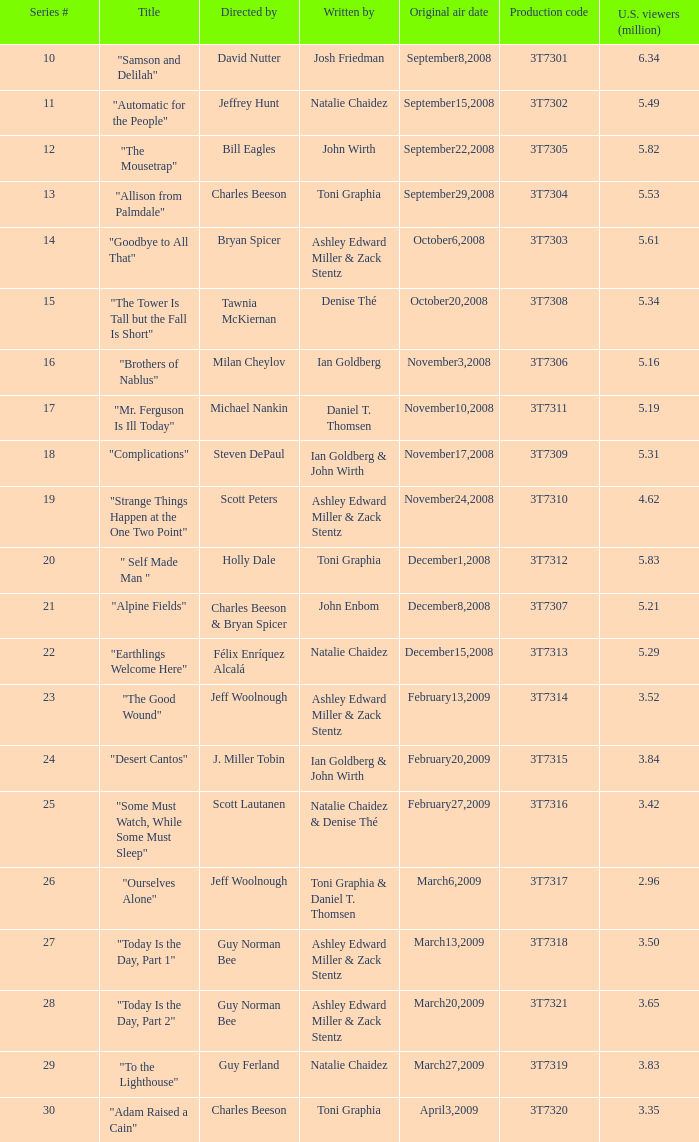Would you be able to parse every entry in this table? {'header': ['Series #', 'Title', 'Directed by', 'Written by', 'Original air date', 'Production code', 'U.S. viewers (million)'], 'rows': [['10', '"Samson and Delilah"', 'David Nutter', 'Josh Friedman', 'September8,2008', '3T7301', '6.34'], ['11', '"Automatic for the People"', 'Jeffrey Hunt', 'Natalie Chaidez', 'September15,2008', '3T7302', '5.49'], ['12', '"The Mousetrap"', 'Bill Eagles', 'John Wirth', 'September22,2008', '3T7305', '5.82'], ['13', '"Allison from Palmdale"', 'Charles Beeson', 'Toni Graphia', 'September29,2008', '3T7304', '5.53'], ['14', '"Goodbye to All That"', 'Bryan Spicer', 'Ashley Edward Miller & Zack Stentz', 'October6,2008', '3T7303', '5.61'], ['15', '"The Tower Is Tall but the Fall Is Short"', 'Tawnia McKiernan', 'Denise Thé', 'October20,2008', '3T7308', '5.34'], ['16', '"Brothers of Nablus"', 'Milan Cheylov', 'Ian Goldberg', 'November3,2008', '3T7306', '5.16'], ['17', '"Mr. Ferguson Is Ill Today"', 'Michael Nankin', 'Daniel T. Thomsen', 'November10,2008', '3T7311', '5.19'], ['18', '"Complications"', 'Steven DePaul', 'Ian Goldberg & John Wirth', 'November17,2008', '3T7309', '5.31'], ['19', '"Strange Things Happen at the One Two Point"', 'Scott Peters', 'Ashley Edward Miller & Zack Stentz', 'November24,2008', '3T7310', '4.62'], ['20', '" Self Made Man "', 'Holly Dale', 'Toni Graphia', 'December1,2008', '3T7312', '5.83'], ['21', '"Alpine Fields"', 'Charles Beeson & Bryan Spicer', 'John Enbom', 'December8,2008', '3T7307', '5.21'], ['22', '"Earthlings Welcome Here"', 'Félix Enríquez Alcalá', 'Natalie Chaidez', 'December15,2008', '3T7313', '5.29'], ['23', '"The Good Wound"', 'Jeff Woolnough', 'Ashley Edward Miller & Zack Stentz', 'February13,2009', '3T7314', '3.52'], ['24', '"Desert Cantos"', 'J. Miller Tobin', 'Ian Goldberg & John Wirth', 'February20,2009', '3T7315', '3.84'], ['25', '"Some Must Watch, While Some Must Sleep"', 'Scott Lautanen', 'Natalie Chaidez & Denise Thé', 'February27,2009', '3T7316', '3.42'], ['26', '"Ourselves Alone"', 'Jeff Woolnough', 'Toni Graphia & Daniel T. Thomsen', 'March6,2009', '3T7317', '2.96'], ['27', '"Today Is the Day, Part 1"', 'Guy Norman Bee', 'Ashley Edward Miller & Zack Stentz', 'March13,2009', '3T7318', '3.50'], ['28', '"Today Is the Day, Part 2"', 'Guy Norman Bee', 'Ashley Edward Miller & Zack Stentz', 'March20,2009', '3T7321', '3.65'], ['29', '"To the Lighthouse"', 'Guy Ferland', 'Natalie Chaidez', 'March27,2009', '3T7319', '3.83'], ['30', '"Adam Raised a Cain"', 'Charles Beeson', 'Toni Graphia', 'April3,2009', '3T7320', '3.35']]} Which episode number was directed by Bill Eagles? 12.0. 